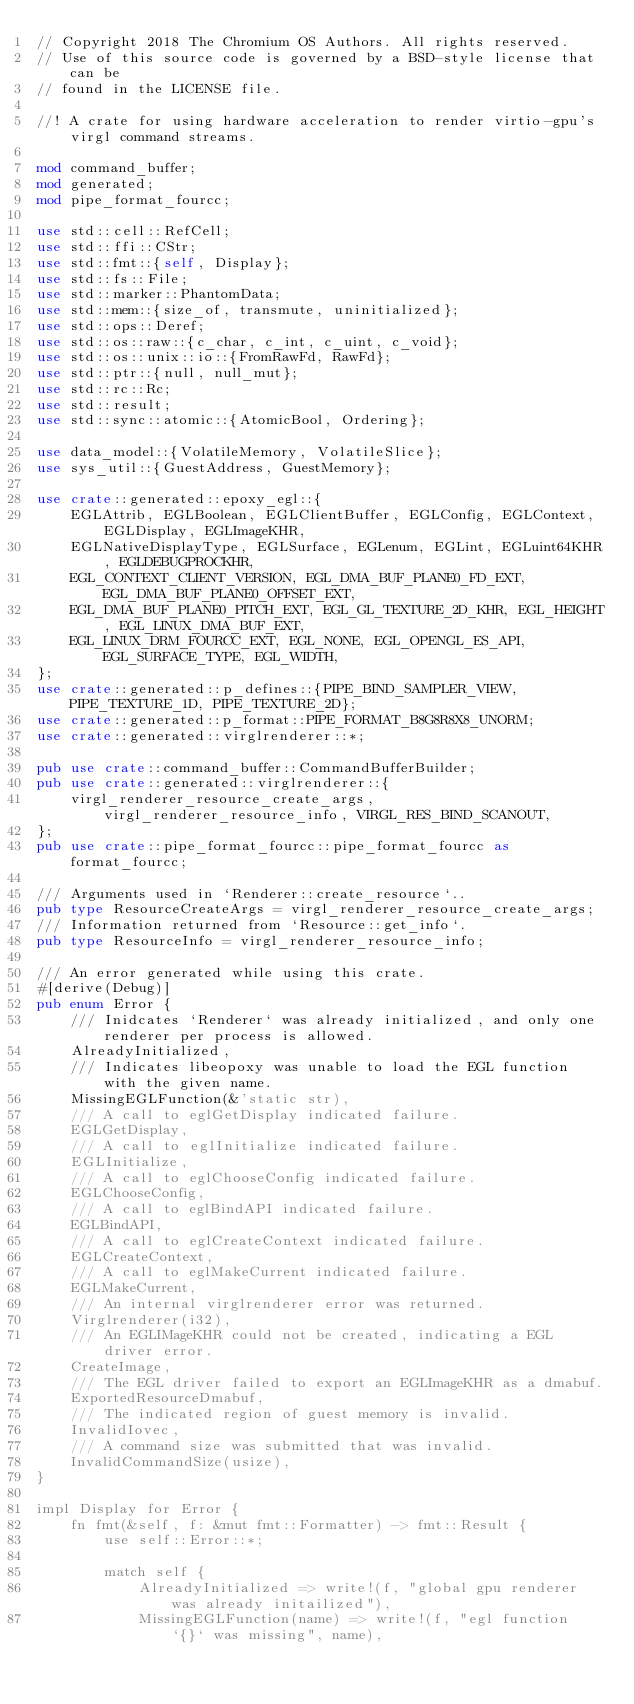Convert code to text. <code><loc_0><loc_0><loc_500><loc_500><_Rust_>// Copyright 2018 The Chromium OS Authors. All rights reserved.
// Use of this source code is governed by a BSD-style license that can be
// found in the LICENSE file.

//! A crate for using hardware acceleration to render virtio-gpu's virgl command streams.

mod command_buffer;
mod generated;
mod pipe_format_fourcc;

use std::cell::RefCell;
use std::ffi::CStr;
use std::fmt::{self, Display};
use std::fs::File;
use std::marker::PhantomData;
use std::mem::{size_of, transmute, uninitialized};
use std::ops::Deref;
use std::os::raw::{c_char, c_int, c_uint, c_void};
use std::os::unix::io::{FromRawFd, RawFd};
use std::ptr::{null, null_mut};
use std::rc::Rc;
use std::result;
use std::sync::atomic::{AtomicBool, Ordering};

use data_model::{VolatileMemory, VolatileSlice};
use sys_util::{GuestAddress, GuestMemory};

use crate::generated::epoxy_egl::{
    EGLAttrib, EGLBoolean, EGLClientBuffer, EGLConfig, EGLContext, EGLDisplay, EGLImageKHR,
    EGLNativeDisplayType, EGLSurface, EGLenum, EGLint, EGLuint64KHR, EGLDEBUGPROCKHR,
    EGL_CONTEXT_CLIENT_VERSION, EGL_DMA_BUF_PLANE0_FD_EXT, EGL_DMA_BUF_PLANE0_OFFSET_EXT,
    EGL_DMA_BUF_PLANE0_PITCH_EXT, EGL_GL_TEXTURE_2D_KHR, EGL_HEIGHT, EGL_LINUX_DMA_BUF_EXT,
    EGL_LINUX_DRM_FOURCC_EXT, EGL_NONE, EGL_OPENGL_ES_API, EGL_SURFACE_TYPE, EGL_WIDTH,
};
use crate::generated::p_defines::{PIPE_BIND_SAMPLER_VIEW, PIPE_TEXTURE_1D, PIPE_TEXTURE_2D};
use crate::generated::p_format::PIPE_FORMAT_B8G8R8X8_UNORM;
use crate::generated::virglrenderer::*;

pub use crate::command_buffer::CommandBufferBuilder;
pub use crate::generated::virglrenderer::{
    virgl_renderer_resource_create_args, virgl_renderer_resource_info, VIRGL_RES_BIND_SCANOUT,
};
pub use crate::pipe_format_fourcc::pipe_format_fourcc as format_fourcc;

/// Arguments used in `Renderer::create_resource`..
pub type ResourceCreateArgs = virgl_renderer_resource_create_args;
/// Information returned from `Resource::get_info`.
pub type ResourceInfo = virgl_renderer_resource_info;

/// An error generated while using this crate.
#[derive(Debug)]
pub enum Error {
    /// Inidcates `Renderer` was already initialized, and only one renderer per process is allowed.
    AlreadyInitialized,
    /// Indicates libeopoxy was unable to load the EGL function with the given name.
    MissingEGLFunction(&'static str),
    /// A call to eglGetDisplay indicated failure.
    EGLGetDisplay,
    /// A call to eglInitialize indicated failure.
    EGLInitialize,
    /// A call to eglChooseConfig indicated failure.
    EGLChooseConfig,
    /// A call to eglBindAPI indicated failure.
    EGLBindAPI,
    /// A call to eglCreateContext indicated failure.
    EGLCreateContext,
    /// A call to eglMakeCurrent indicated failure.
    EGLMakeCurrent,
    /// An internal virglrenderer error was returned.
    Virglrenderer(i32),
    /// An EGLIMageKHR could not be created, indicating a EGL driver error.
    CreateImage,
    /// The EGL driver failed to export an EGLImageKHR as a dmabuf.
    ExportedResourceDmabuf,
    /// The indicated region of guest memory is invalid.
    InvalidIovec,
    /// A command size was submitted that was invalid.
    InvalidCommandSize(usize),
}

impl Display for Error {
    fn fmt(&self, f: &mut fmt::Formatter) -> fmt::Result {
        use self::Error::*;

        match self {
            AlreadyInitialized => write!(f, "global gpu renderer was already initailized"),
            MissingEGLFunction(name) => write!(f, "egl function `{}` was missing", name),</code> 